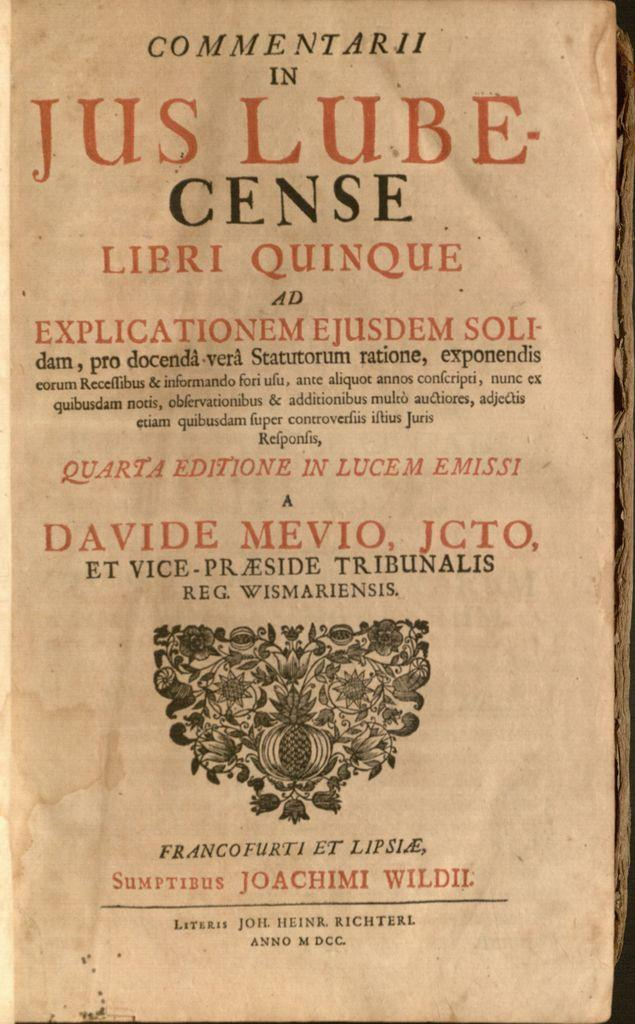<image>
Share a concise interpretation of the image provided. An old paper with "Commentary in Jus Lube-Cense" written at the top. 